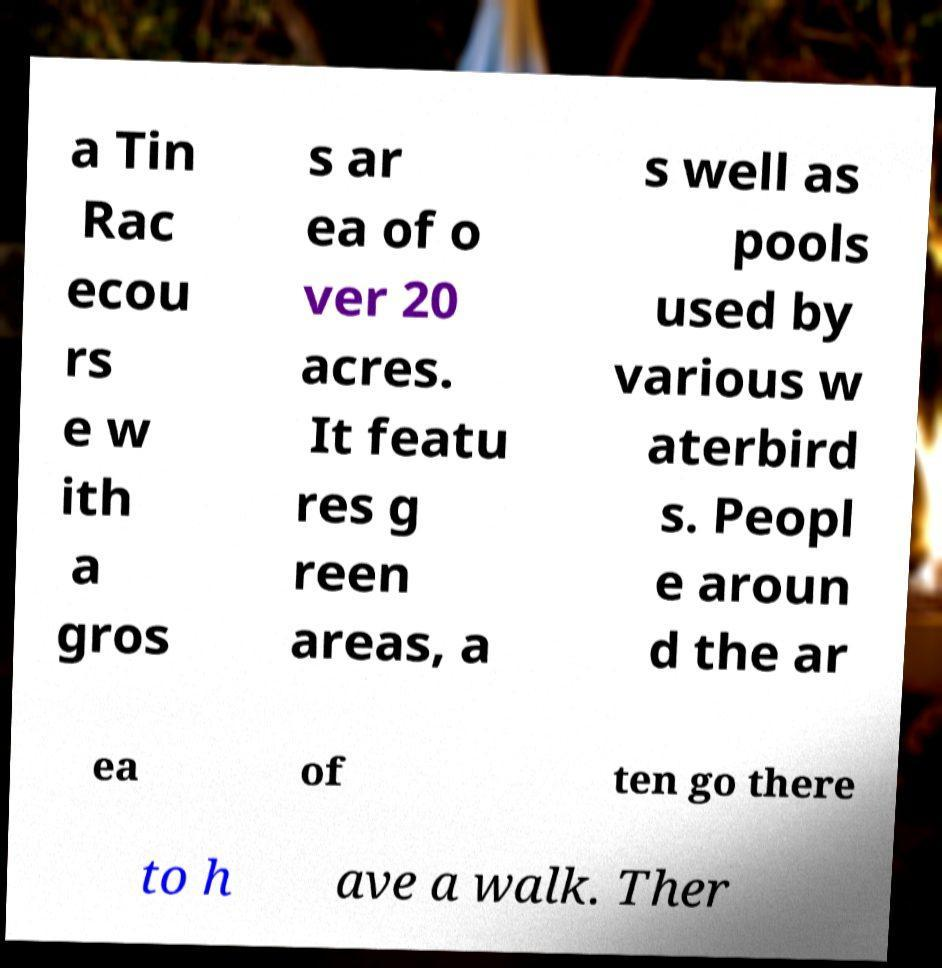Can you accurately transcribe the text from the provided image for me? a Tin Rac ecou rs e w ith a gros s ar ea of o ver 20 acres. It featu res g reen areas, a s well as pools used by various w aterbird s. Peopl e aroun d the ar ea of ten go there to h ave a walk. Ther 